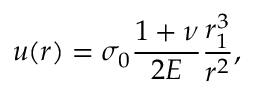Convert formula to latex. <formula><loc_0><loc_0><loc_500><loc_500>u ( r ) = \sigma _ { 0 } \frac { 1 + \nu } { 2 E } \frac { r _ { 1 } ^ { 3 } } { r ^ { 2 } } ,</formula> 